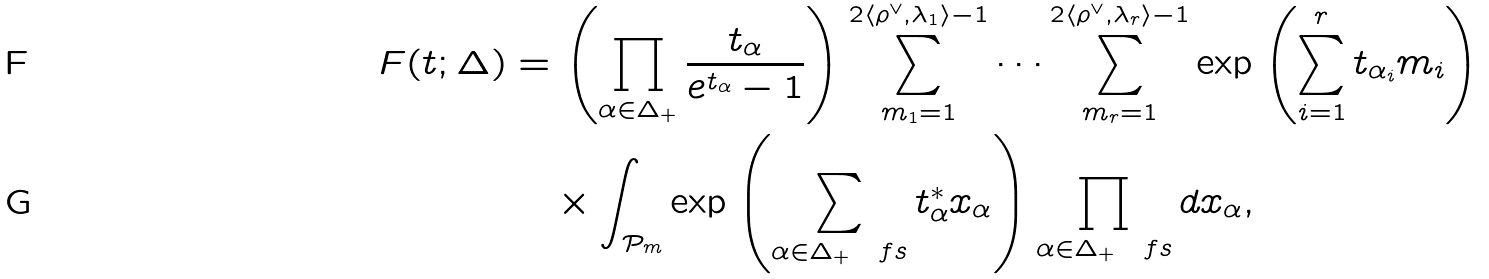<formula> <loc_0><loc_0><loc_500><loc_500>F ( t ; \Delta ) & = \left ( \prod _ { \alpha \in \Delta _ { + } } \frac { t _ { \alpha } } { e ^ { t _ { \alpha } } - 1 } \right ) \sum _ { m _ { 1 } = 1 } ^ { 2 \langle \rho ^ { \vee } , \lambda _ { 1 } \rangle - 1 } \cdots \sum _ { m _ { r } = 1 } ^ { 2 \langle \rho ^ { \vee } , \lambda _ { r } \rangle - 1 } \exp \left ( \sum _ { i = 1 } ^ { r } t _ { \alpha _ { i } } m _ { i } \right ) \\ & \quad \times \int _ { \mathcal { P } _ { m } } \exp \left ( \sum _ { \alpha \in \Delta _ { + } \ \ f s } t ^ { * } _ { \alpha } x _ { \alpha } \right ) \prod _ { \alpha \in \Delta _ { + } \ \ f s } d x _ { \alpha } ,</formula> 